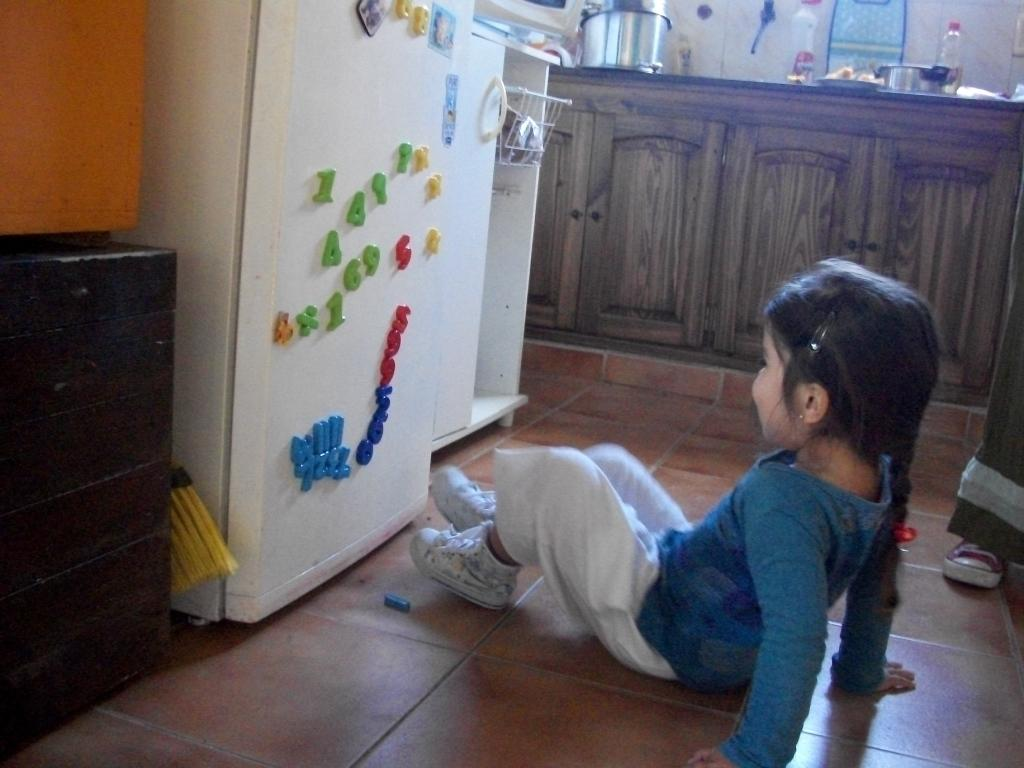<image>
Offer a succinct explanation of the picture presented. a child sits in front of a fridge with letters and numbers on it including 'a' 